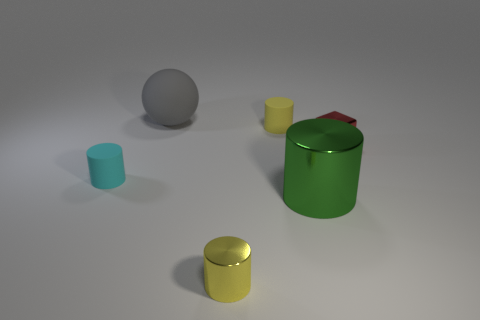Is there any other thing that is the same material as the big green thing?
Provide a succinct answer. Yes. How many objects are either tiny rubber balls or tiny metal things that are right of the tiny shiny cylinder?
Ensure brevity in your answer.  1. There is a rubber thing that is the same color as the tiny metal cylinder; what size is it?
Ensure brevity in your answer.  Small. There is a tiny shiny thing in front of the large metallic cylinder; what is its shape?
Make the answer very short. Cylinder. Is the color of the small cylinder on the left side of the small yellow shiny cylinder the same as the tiny shiny cube?
Your answer should be very brief. No. What material is the other cylinder that is the same color as the tiny shiny cylinder?
Keep it short and to the point. Rubber. Does the cylinder that is on the left side of the sphere have the same size as the big green cylinder?
Ensure brevity in your answer.  No. Are there any big cylinders that have the same color as the ball?
Give a very brief answer. No. Is there a tiny yellow matte cylinder left of the small cylinder in front of the tiny cyan rubber thing?
Your answer should be very brief. No. Are there any blue cylinders made of the same material as the large gray object?
Ensure brevity in your answer.  No. 